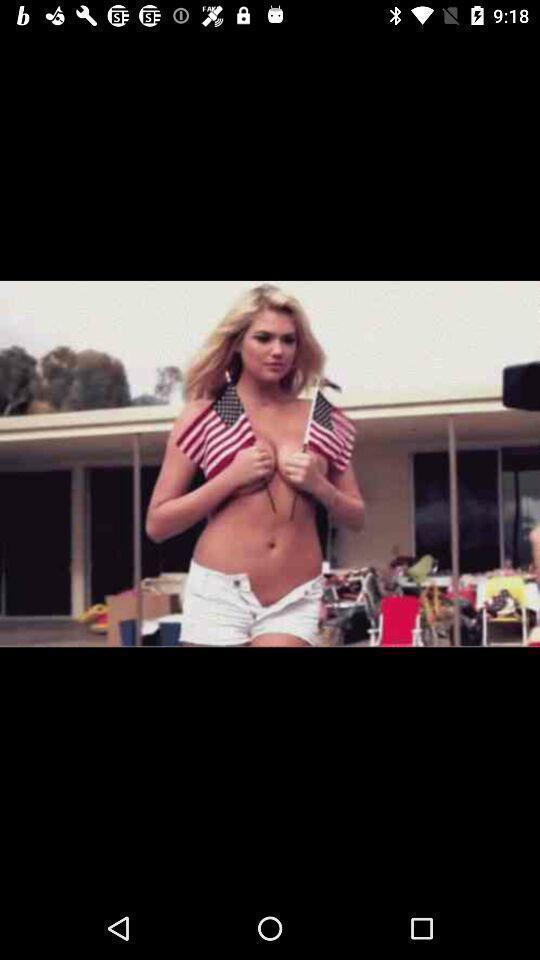Describe the key features of this screenshot. Screen showing an image. 